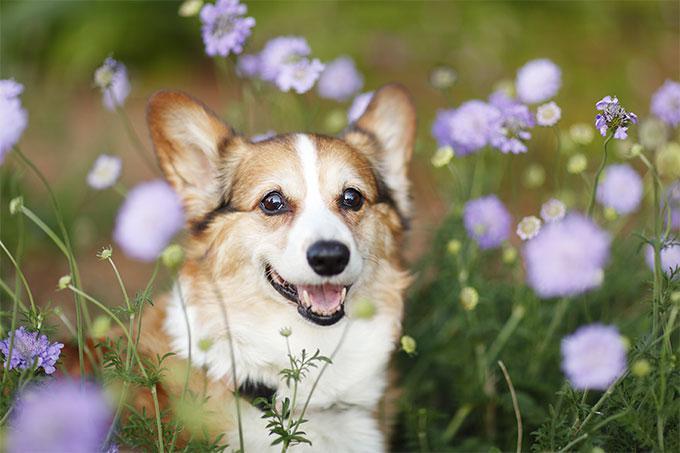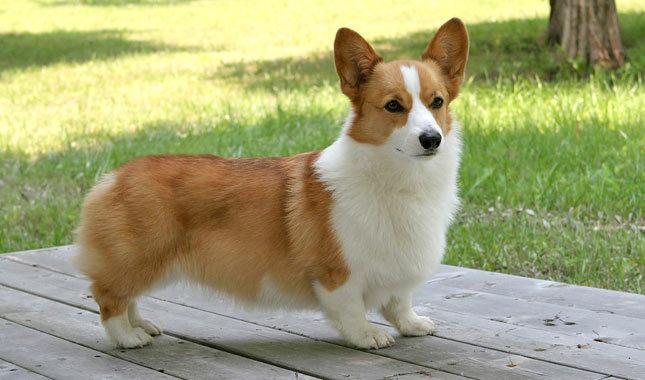The first image is the image on the left, the second image is the image on the right. Evaluate the accuracy of this statement regarding the images: "The entire dog is visible in the image on the left.". Is it true? Answer yes or no. No. 